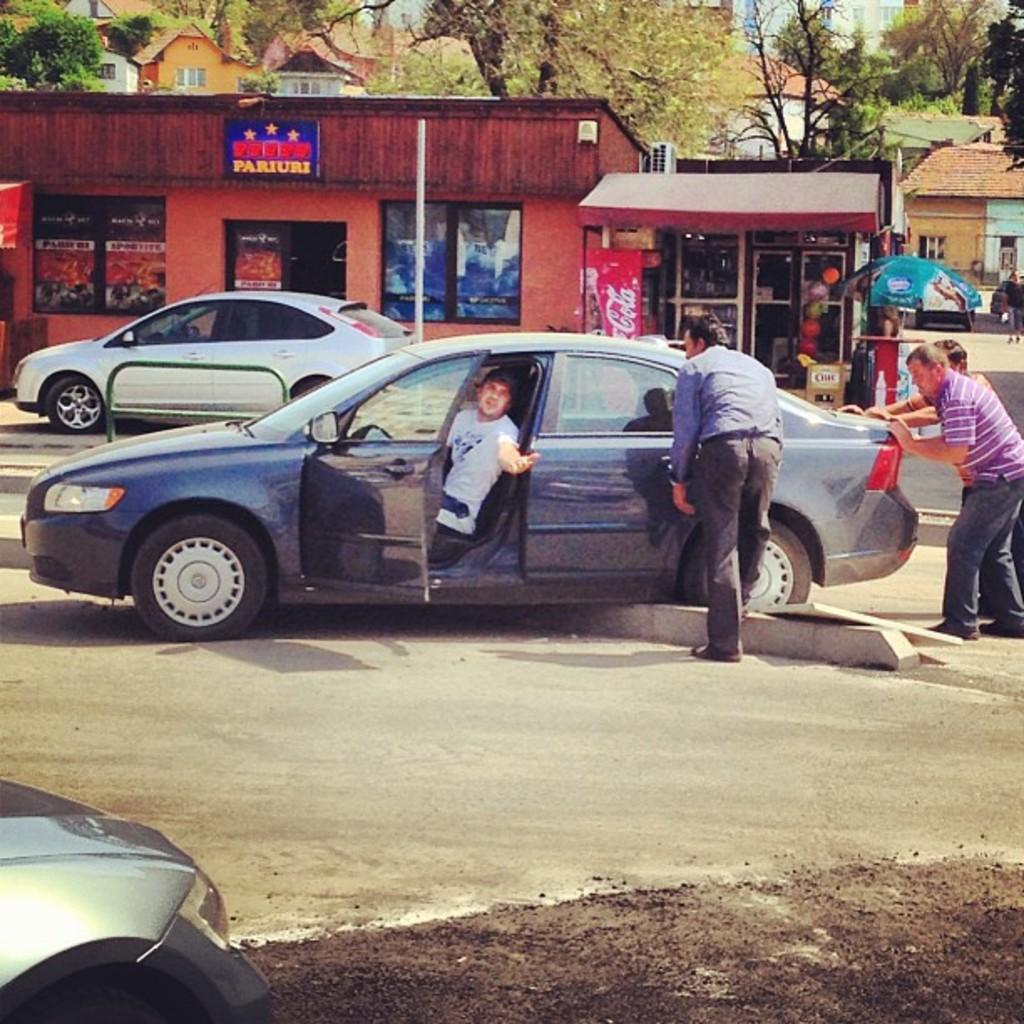In one or two sentences, can you explain what this image depicts? In this picture there is a car on the road. In this car, a man is sitting and is waving at the another man. To the right, there are two persons who are pushing the car. There is a white car. There is a shop. At the background, there is a tree and a house. To the left, there is also another grey car. 